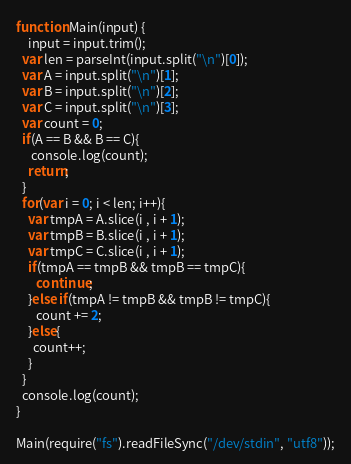<code> <loc_0><loc_0><loc_500><loc_500><_JavaScript_>function Main(input) {
	input = input.trim();
  var len = parseInt(input.split("\n")[0]);
  var A = input.split("\n")[1];
  var B = input.split("\n")[2];
  var C = input.split("\n")[3];
  var count = 0;
  if(A == B && B == C){
     console.log(count);
    return;
  }
  for(var i = 0; i < len; i++){
    var tmpA = A.slice(i , i + 1);
    var tmpB = B.slice(i , i + 1);
    var tmpC = C.slice(i , i + 1);
    if(tmpA == tmpB && tmpB == tmpC){
       continue;
    }else if(tmpA != tmpB && tmpB != tmpC){
       count += 2;
    }else{
      count++;
    }
  }
  console.log(count);
}

Main(require("fs").readFileSync("/dev/stdin", "utf8"));
</code> 